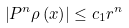Convert formula to latex. <formula><loc_0><loc_0><loc_500><loc_500>\left | P ^ { n } \rho \left ( x \right ) \right | \leq c _ { 1 } r ^ { n }</formula> 